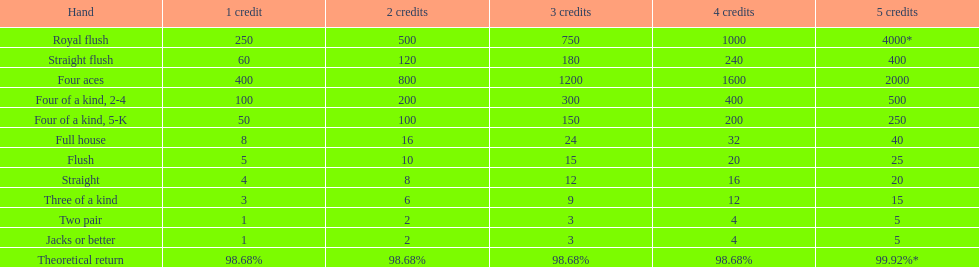Could you parse the entire table? {'header': ['Hand', '1 credit', '2 credits', '3 credits', '4 credits', '5 credits'], 'rows': [['Royal flush', '250', '500', '750', '1000', '4000*'], ['Straight flush', '60', '120', '180', '240', '400'], ['Four aces', '400', '800', '1200', '1600', '2000'], ['Four of a kind, 2-4', '100', '200', '300', '400', '500'], ['Four of a kind, 5-K', '50', '100', '150', '200', '250'], ['Full house', '8', '16', '24', '32', '40'], ['Flush', '5', '10', '15', '20', '25'], ['Straight', '4', '8', '12', '16', '20'], ['Three of a kind', '3', '6', '9', '12', '15'], ['Two pair', '1', '2', '3', '4', '5'], ['Jacks or better', '1', '2', '3', '4', '5'], ['Theoretical return', '98.68%', '98.68%', '98.68%', '98.68%', '99.92%*']]} What is the discrepancy in payout for 3 credits between a straight flush and a royal flush? 570. 